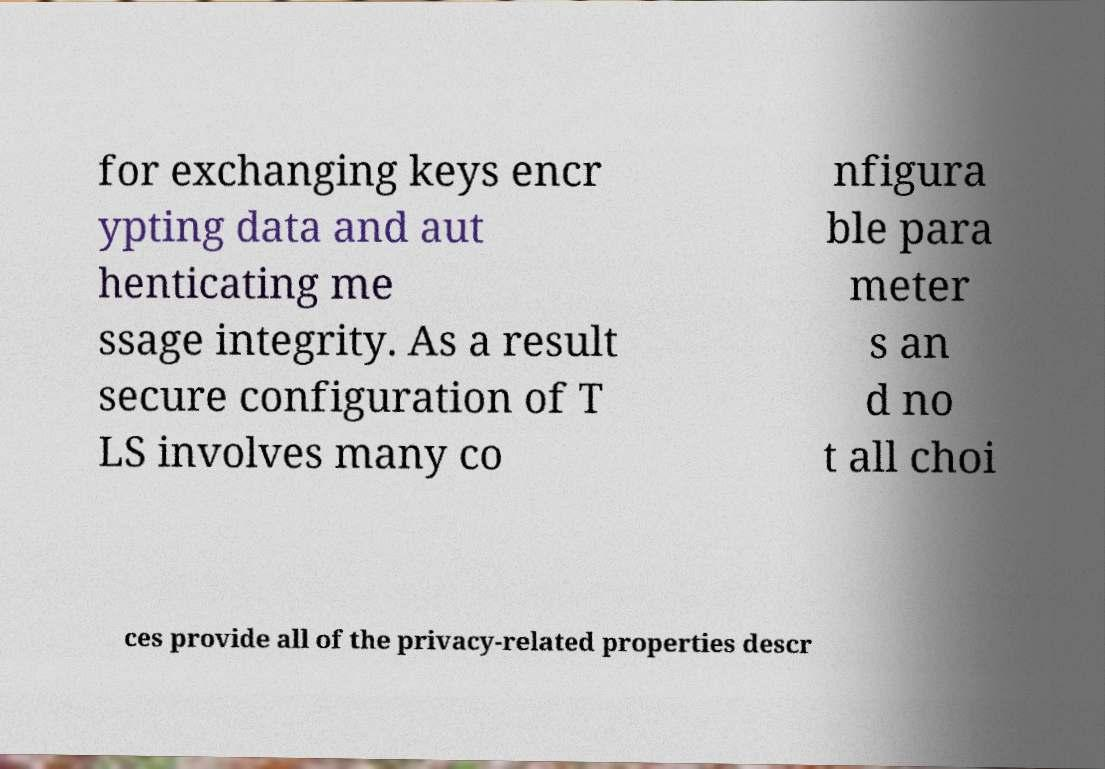Could you extract and type out the text from this image? for exchanging keys encr ypting data and aut henticating me ssage integrity. As a result secure configuration of T LS involves many co nfigura ble para meter s an d no t all choi ces provide all of the privacy-related properties descr 